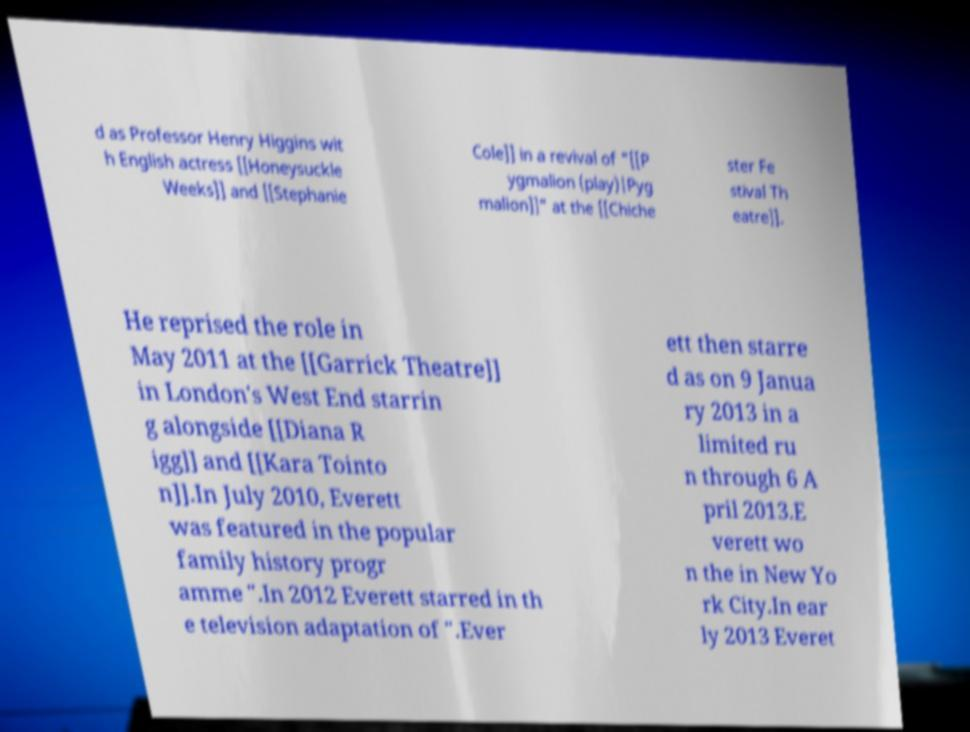What messages or text are displayed in this image? I need them in a readable, typed format. d as Professor Henry Higgins wit h English actress [[Honeysuckle Weeks]] and [[Stephanie Cole]] in a revival of "[[P ygmalion (play)|Pyg malion]]" at the [[Chiche ster Fe stival Th eatre]]. He reprised the role in May 2011 at the [[Garrick Theatre]] in London's West End starrin g alongside [[Diana R igg]] and [[Kara Tointo n]].In July 2010, Everett was featured in the popular family history progr amme ".In 2012 Everett starred in th e television adaptation of ".Ever ett then starre d as on 9 Janua ry 2013 in a limited ru n through 6 A pril 2013.E verett wo n the in New Yo rk City.In ear ly 2013 Everet 